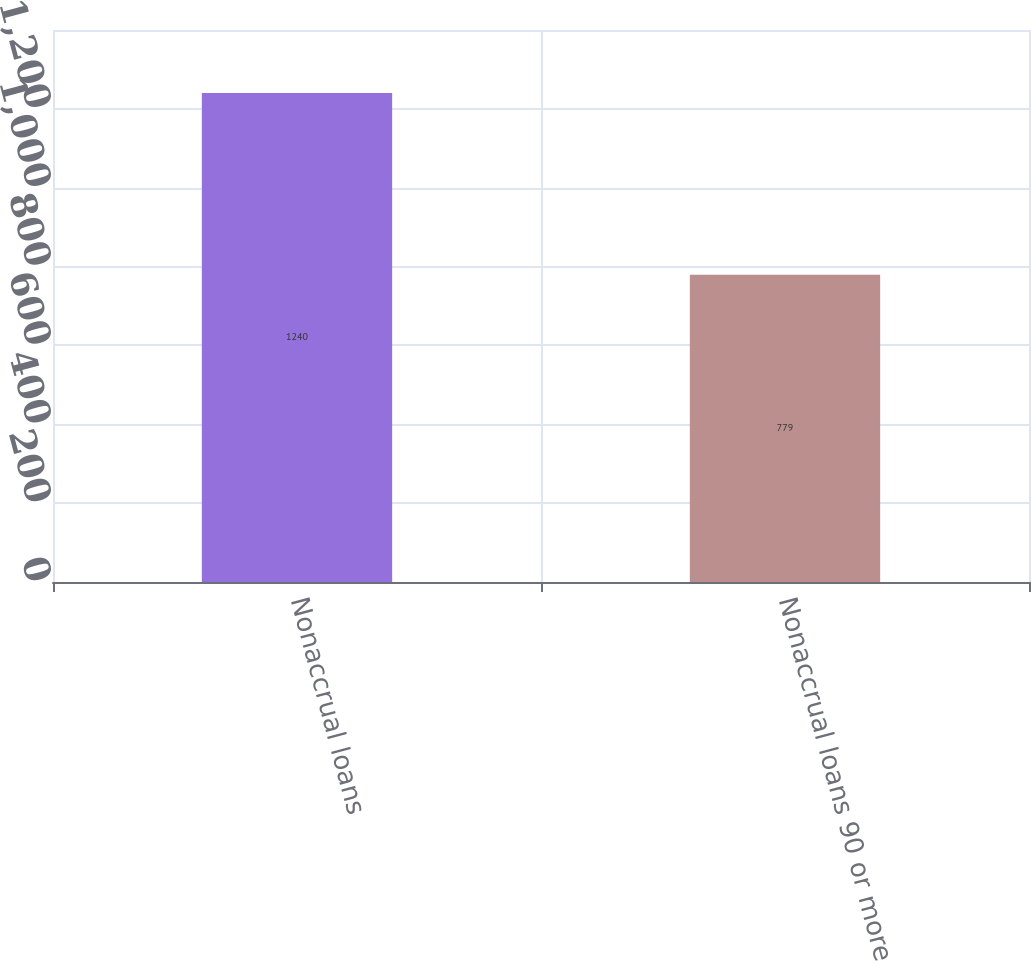Convert chart. <chart><loc_0><loc_0><loc_500><loc_500><bar_chart><fcel>Nonaccrual loans<fcel>Nonaccrual loans 90 or more<nl><fcel>1240<fcel>779<nl></chart> 